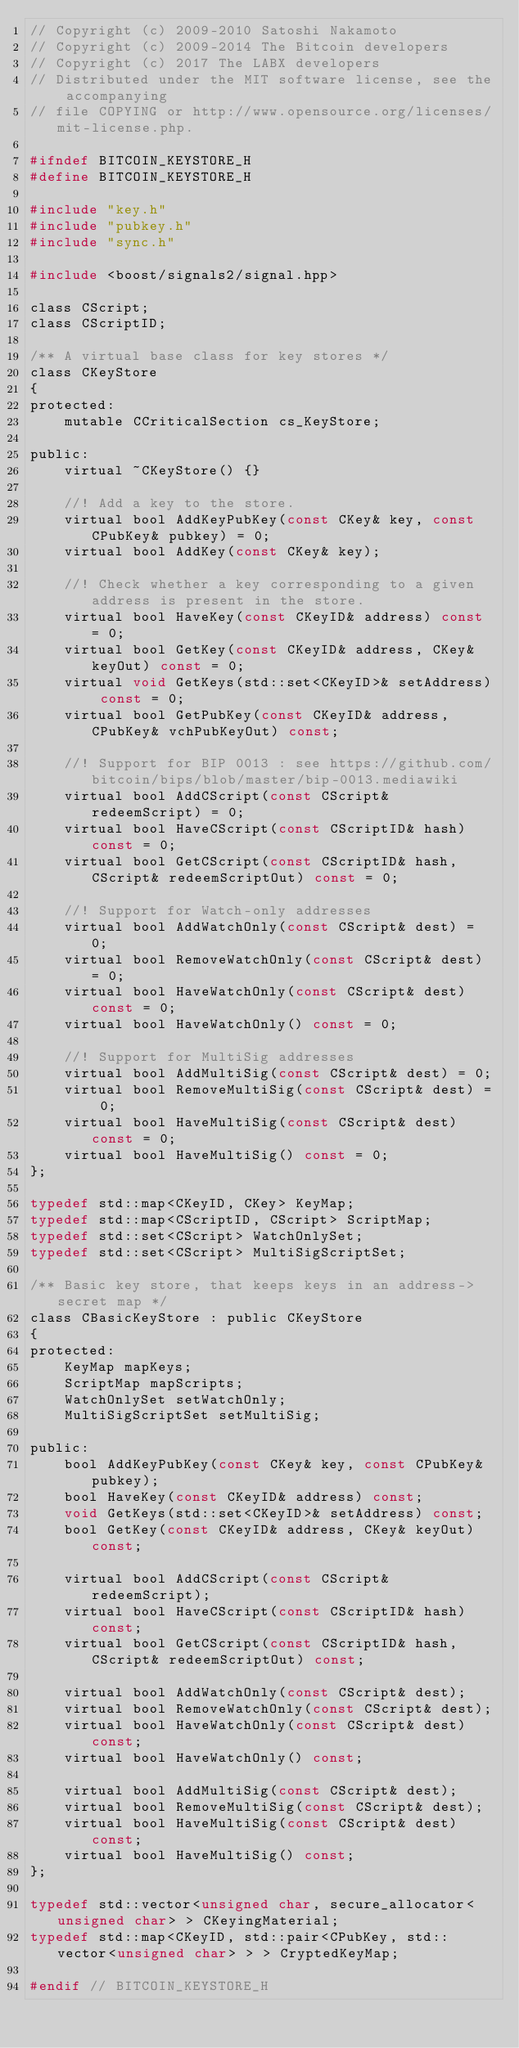Convert code to text. <code><loc_0><loc_0><loc_500><loc_500><_C_>// Copyright (c) 2009-2010 Satoshi Nakamoto
// Copyright (c) 2009-2014 The Bitcoin developers
// Copyright (c) 2017 The LABX developers
// Distributed under the MIT software license, see the accompanying
// file COPYING or http://www.opensource.org/licenses/mit-license.php.

#ifndef BITCOIN_KEYSTORE_H
#define BITCOIN_KEYSTORE_H

#include "key.h"
#include "pubkey.h"
#include "sync.h"

#include <boost/signals2/signal.hpp>

class CScript;
class CScriptID;

/** A virtual base class for key stores */
class CKeyStore
{
protected:
    mutable CCriticalSection cs_KeyStore;

public:
    virtual ~CKeyStore() {}

    //! Add a key to the store.
    virtual bool AddKeyPubKey(const CKey& key, const CPubKey& pubkey) = 0;
    virtual bool AddKey(const CKey& key);

    //! Check whether a key corresponding to a given address is present in the store.
    virtual bool HaveKey(const CKeyID& address) const = 0;
    virtual bool GetKey(const CKeyID& address, CKey& keyOut) const = 0;
    virtual void GetKeys(std::set<CKeyID>& setAddress) const = 0;
    virtual bool GetPubKey(const CKeyID& address, CPubKey& vchPubKeyOut) const;

    //! Support for BIP 0013 : see https://github.com/bitcoin/bips/blob/master/bip-0013.mediawiki
    virtual bool AddCScript(const CScript& redeemScript) = 0;
    virtual bool HaveCScript(const CScriptID& hash) const = 0;
    virtual bool GetCScript(const CScriptID& hash, CScript& redeemScriptOut) const = 0;

    //! Support for Watch-only addresses
    virtual bool AddWatchOnly(const CScript& dest) = 0;
    virtual bool RemoveWatchOnly(const CScript& dest) = 0;
    virtual bool HaveWatchOnly(const CScript& dest) const = 0;
    virtual bool HaveWatchOnly() const = 0;

    //! Support for MultiSig addresses
    virtual bool AddMultiSig(const CScript& dest) = 0;
    virtual bool RemoveMultiSig(const CScript& dest) = 0;
    virtual bool HaveMultiSig(const CScript& dest) const = 0;
    virtual bool HaveMultiSig() const = 0;
};

typedef std::map<CKeyID, CKey> KeyMap;
typedef std::map<CScriptID, CScript> ScriptMap;
typedef std::set<CScript> WatchOnlySet;
typedef std::set<CScript> MultiSigScriptSet;

/** Basic key store, that keeps keys in an address->secret map */
class CBasicKeyStore : public CKeyStore
{
protected:
    KeyMap mapKeys;
    ScriptMap mapScripts;
    WatchOnlySet setWatchOnly;
    MultiSigScriptSet setMultiSig;

public:
    bool AddKeyPubKey(const CKey& key, const CPubKey& pubkey);
    bool HaveKey(const CKeyID& address) const;
    void GetKeys(std::set<CKeyID>& setAddress) const;
    bool GetKey(const CKeyID& address, CKey& keyOut) const;

    virtual bool AddCScript(const CScript& redeemScript);
    virtual bool HaveCScript(const CScriptID& hash) const;
    virtual bool GetCScript(const CScriptID& hash, CScript& redeemScriptOut) const;

    virtual bool AddWatchOnly(const CScript& dest);
    virtual bool RemoveWatchOnly(const CScript& dest);
    virtual bool HaveWatchOnly(const CScript& dest) const;
    virtual bool HaveWatchOnly() const;

    virtual bool AddMultiSig(const CScript& dest);
    virtual bool RemoveMultiSig(const CScript& dest);
    virtual bool HaveMultiSig(const CScript& dest) const;
    virtual bool HaveMultiSig() const;
};

typedef std::vector<unsigned char, secure_allocator<unsigned char> > CKeyingMaterial;
typedef std::map<CKeyID, std::pair<CPubKey, std::vector<unsigned char> > > CryptedKeyMap;

#endif // BITCOIN_KEYSTORE_H
</code> 